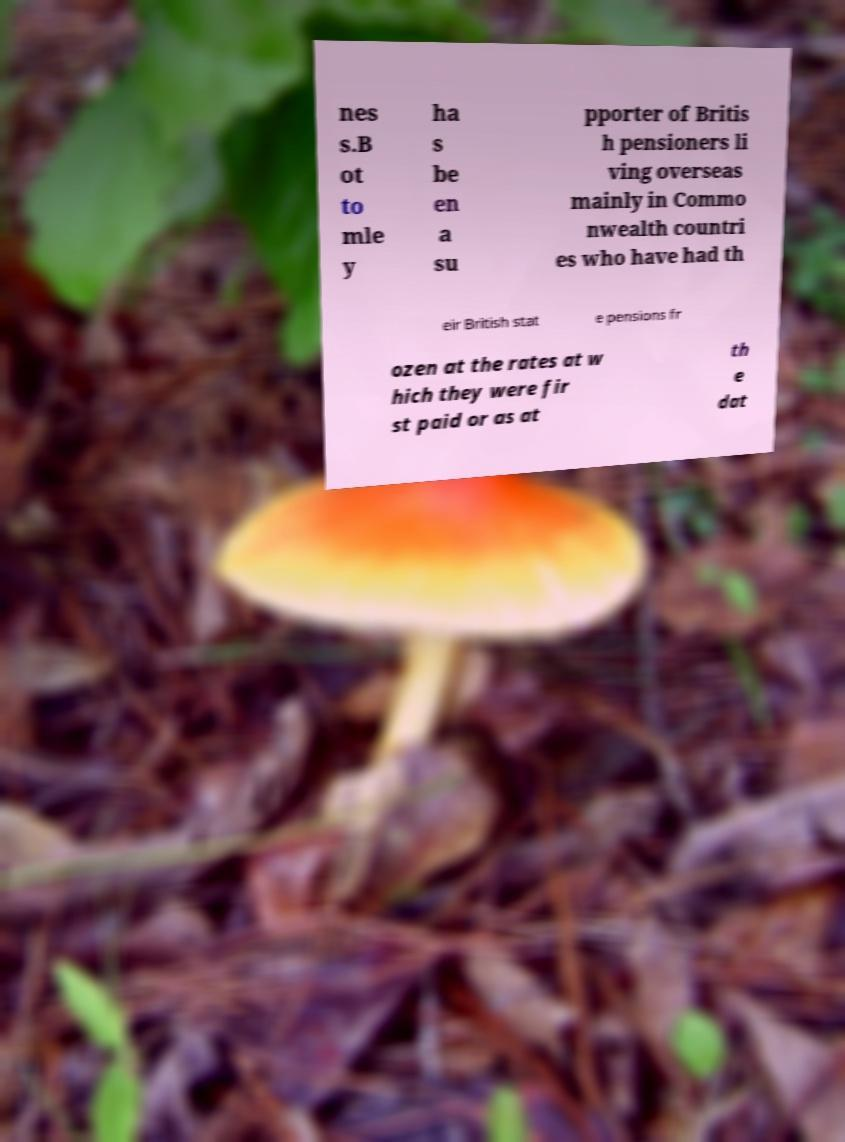Could you assist in decoding the text presented in this image and type it out clearly? nes s.B ot to mle y ha s be en a su pporter of Britis h pensioners li ving overseas mainly in Commo nwealth countri es who have had th eir British stat e pensions fr ozen at the rates at w hich they were fir st paid or as at th e dat 